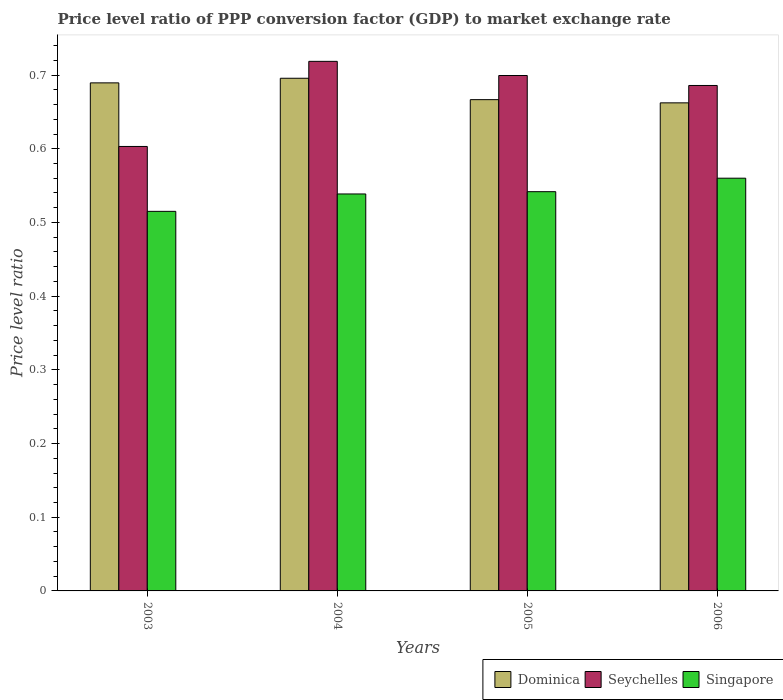How many different coloured bars are there?
Offer a very short reply. 3. How many groups of bars are there?
Provide a succinct answer. 4. How many bars are there on the 4th tick from the left?
Ensure brevity in your answer.  3. What is the label of the 3rd group of bars from the left?
Your answer should be compact. 2005. In how many cases, is the number of bars for a given year not equal to the number of legend labels?
Provide a short and direct response. 0. What is the price level ratio in Dominica in 2003?
Keep it short and to the point. 0.69. Across all years, what is the maximum price level ratio in Singapore?
Give a very brief answer. 0.56. Across all years, what is the minimum price level ratio in Dominica?
Your answer should be compact. 0.66. In which year was the price level ratio in Seychelles maximum?
Offer a terse response. 2004. In which year was the price level ratio in Singapore minimum?
Offer a terse response. 2003. What is the total price level ratio in Dominica in the graph?
Make the answer very short. 2.71. What is the difference between the price level ratio in Seychelles in 2005 and that in 2006?
Your answer should be very brief. 0.01. What is the difference between the price level ratio in Dominica in 2003 and the price level ratio in Singapore in 2004?
Your answer should be very brief. 0.15. What is the average price level ratio in Dominica per year?
Offer a terse response. 0.68. In the year 2003, what is the difference between the price level ratio in Singapore and price level ratio in Seychelles?
Offer a very short reply. -0.09. What is the ratio of the price level ratio in Dominica in 2004 to that in 2005?
Provide a short and direct response. 1.04. Is the price level ratio in Seychelles in 2004 less than that in 2006?
Keep it short and to the point. No. Is the difference between the price level ratio in Singapore in 2003 and 2006 greater than the difference between the price level ratio in Seychelles in 2003 and 2006?
Your response must be concise. Yes. What is the difference between the highest and the second highest price level ratio in Dominica?
Provide a succinct answer. 0.01. What is the difference between the highest and the lowest price level ratio in Singapore?
Provide a succinct answer. 0.04. What does the 3rd bar from the left in 2005 represents?
Your answer should be very brief. Singapore. What does the 2nd bar from the right in 2006 represents?
Give a very brief answer. Seychelles. How many bars are there?
Ensure brevity in your answer.  12. Are the values on the major ticks of Y-axis written in scientific E-notation?
Your answer should be very brief. No. Does the graph contain any zero values?
Ensure brevity in your answer.  No. Does the graph contain grids?
Provide a succinct answer. No. How many legend labels are there?
Offer a terse response. 3. How are the legend labels stacked?
Offer a very short reply. Horizontal. What is the title of the graph?
Provide a succinct answer. Price level ratio of PPP conversion factor (GDP) to market exchange rate. Does "Zimbabwe" appear as one of the legend labels in the graph?
Offer a very short reply. No. What is the label or title of the X-axis?
Offer a very short reply. Years. What is the label or title of the Y-axis?
Offer a very short reply. Price level ratio. What is the Price level ratio of Dominica in 2003?
Your answer should be very brief. 0.69. What is the Price level ratio in Seychelles in 2003?
Provide a succinct answer. 0.6. What is the Price level ratio in Singapore in 2003?
Make the answer very short. 0.52. What is the Price level ratio of Dominica in 2004?
Provide a succinct answer. 0.7. What is the Price level ratio in Seychelles in 2004?
Your answer should be compact. 0.72. What is the Price level ratio in Singapore in 2004?
Ensure brevity in your answer.  0.54. What is the Price level ratio in Dominica in 2005?
Ensure brevity in your answer.  0.67. What is the Price level ratio of Seychelles in 2005?
Offer a terse response. 0.7. What is the Price level ratio in Singapore in 2005?
Your answer should be very brief. 0.54. What is the Price level ratio of Dominica in 2006?
Keep it short and to the point. 0.66. What is the Price level ratio in Seychelles in 2006?
Your response must be concise. 0.69. What is the Price level ratio in Singapore in 2006?
Your answer should be compact. 0.56. Across all years, what is the maximum Price level ratio of Dominica?
Make the answer very short. 0.7. Across all years, what is the maximum Price level ratio in Seychelles?
Ensure brevity in your answer.  0.72. Across all years, what is the maximum Price level ratio in Singapore?
Offer a terse response. 0.56. Across all years, what is the minimum Price level ratio in Dominica?
Your answer should be compact. 0.66. Across all years, what is the minimum Price level ratio in Seychelles?
Give a very brief answer. 0.6. Across all years, what is the minimum Price level ratio of Singapore?
Offer a very short reply. 0.52. What is the total Price level ratio of Dominica in the graph?
Make the answer very short. 2.71. What is the total Price level ratio in Seychelles in the graph?
Offer a very short reply. 2.71. What is the total Price level ratio in Singapore in the graph?
Provide a succinct answer. 2.16. What is the difference between the Price level ratio in Dominica in 2003 and that in 2004?
Your response must be concise. -0.01. What is the difference between the Price level ratio of Seychelles in 2003 and that in 2004?
Your answer should be very brief. -0.12. What is the difference between the Price level ratio in Singapore in 2003 and that in 2004?
Provide a short and direct response. -0.02. What is the difference between the Price level ratio in Dominica in 2003 and that in 2005?
Your response must be concise. 0.02. What is the difference between the Price level ratio in Seychelles in 2003 and that in 2005?
Keep it short and to the point. -0.1. What is the difference between the Price level ratio in Singapore in 2003 and that in 2005?
Provide a short and direct response. -0.03. What is the difference between the Price level ratio of Dominica in 2003 and that in 2006?
Your answer should be very brief. 0.03. What is the difference between the Price level ratio of Seychelles in 2003 and that in 2006?
Make the answer very short. -0.08. What is the difference between the Price level ratio in Singapore in 2003 and that in 2006?
Ensure brevity in your answer.  -0.04. What is the difference between the Price level ratio of Dominica in 2004 and that in 2005?
Your answer should be very brief. 0.03. What is the difference between the Price level ratio of Seychelles in 2004 and that in 2005?
Keep it short and to the point. 0.02. What is the difference between the Price level ratio of Singapore in 2004 and that in 2005?
Provide a succinct answer. -0. What is the difference between the Price level ratio of Dominica in 2004 and that in 2006?
Offer a very short reply. 0.03. What is the difference between the Price level ratio in Seychelles in 2004 and that in 2006?
Offer a very short reply. 0.03. What is the difference between the Price level ratio in Singapore in 2004 and that in 2006?
Offer a very short reply. -0.02. What is the difference between the Price level ratio of Dominica in 2005 and that in 2006?
Your response must be concise. 0. What is the difference between the Price level ratio in Seychelles in 2005 and that in 2006?
Your answer should be very brief. 0.01. What is the difference between the Price level ratio of Singapore in 2005 and that in 2006?
Offer a terse response. -0.02. What is the difference between the Price level ratio in Dominica in 2003 and the Price level ratio in Seychelles in 2004?
Your answer should be compact. -0.03. What is the difference between the Price level ratio in Dominica in 2003 and the Price level ratio in Singapore in 2004?
Offer a very short reply. 0.15. What is the difference between the Price level ratio of Seychelles in 2003 and the Price level ratio of Singapore in 2004?
Provide a succinct answer. 0.06. What is the difference between the Price level ratio in Dominica in 2003 and the Price level ratio in Seychelles in 2005?
Your answer should be very brief. -0.01. What is the difference between the Price level ratio in Dominica in 2003 and the Price level ratio in Singapore in 2005?
Your answer should be very brief. 0.15. What is the difference between the Price level ratio in Seychelles in 2003 and the Price level ratio in Singapore in 2005?
Make the answer very short. 0.06. What is the difference between the Price level ratio in Dominica in 2003 and the Price level ratio in Seychelles in 2006?
Offer a terse response. 0. What is the difference between the Price level ratio in Dominica in 2003 and the Price level ratio in Singapore in 2006?
Your response must be concise. 0.13. What is the difference between the Price level ratio of Seychelles in 2003 and the Price level ratio of Singapore in 2006?
Provide a short and direct response. 0.04. What is the difference between the Price level ratio in Dominica in 2004 and the Price level ratio in Seychelles in 2005?
Provide a short and direct response. -0. What is the difference between the Price level ratio in Dominica in 2004 and the Price level ratio in Singapore in 2005?
Provide a succinct answer. 0.15. What is the difference between the Price level ratio of Seychelles in 2004 and the Price level ratio of Singapore in 2005?
Your response must be concise. 0.18. What is the difference between the Price level ratio in Dominica in 2004 and the Price level ratio in Seychelles in 2006?
Give a very brief answer. 0.01. What is the difference between the Price level ratio of Dominica in 2004 and the Price level ratio of Singapore in 2006?
Your response must be concise. 0.14. What is the difference between the Price level ratio in Seychelles in 2004 and the Price level ratio in Singapore in 2006?
Ensure brevity in your answer.  0.16. What is the difference between the Price level ratio of Dominica in 2005 and the Price level ratio of Seychelles in 2006?
Your response must be concise. -0.02. What is the difference between the Price level ratio of Dominica in 2005 and the Price level ratio of Singapore in 2006?
Your answer should be very brief. 0.11. What is the difference between the Price level ratio of Seychelles in 2005 and the Price level ratio of Singapore in 2006?
Give a very brief answer. 0.14. What is the average Price level ratio of Dominica per year?
Provide a short and direct response. 0.68. What is the average Price level ratio of Seychelles per year?
Give a very brief answer. 0.68. What is the average Price level ratio in Singapore per year?
Offer a terse response. 0.54. In the year 2003, what is the difference between the Price level ratio in Dominica and Price level ratio in Seychelles?
Offer a terse response. 0.09. In the year 2003, what is the difference between the Price level ratio of Dominica and Price level ratio of Singapore?
Keep it short and to the point. 0.17. In the year 2003, what is the difference between the Price level ratio of Seychelles and Price level ratio of Singapore?
Keep it short and to the point. 0.09. In the year 2004, what is the difference between the Price level ratio of Dominica and Price level ratio of Seychelles?
Ensure brevity in your answer.  -0.02. In the year 2004, what is the difference between the Price level ratio in Dominica and Price level ratio in Singapore?
Your answer should be very brief. 0.16. In the year 2004, what is the difference between the Price level ratio of Seychelles and Price level ratio of Singapore?
Your answer should be very brief. 0.18. In the year 2005, what is the difference between the Price level ratio in Dominica and Price level ratio in Seychelles?
Keep it short and to the point. -0.03. In the year 2005, what is the difference between the Price level ratio in Dominica and Price level ratio in Singapore?
Keep it short and to the point. 0.12. In the year 2005, what is the difference between the Price level ratio of Seychelles and Price level ratio of Singapore?
Give a very brief answer. 0.16. In the year 2006, what is the difference between the Price level ratio of Dominica and Price level ratio of Seychelles?
Provide a succinct answer. -0.02. In the year 2006, what is the difference between the Price level ratio in Dominica and Price level ratio in Singapore?
Your answer should be compact. 0.1. In the year 2006, what is the difference between the Price level ratio of Seychelles and Price level ratio of Singapore?
Provide a succinct answer. 0.13. What is the ratio of the Price level ratio of Dominica in 2003 to that in 2004?
Ensure brevity in your answer.  0.99. What is the ratio of the Price level ratio in Seychelles in 2003 to that in 2004?
Your response must be concise. 0.84. What is the ratio of the Price level ratio of Singapore in 2003 to that in 2004?
Keep it short and to the point. 0.96. What is the ratio of the Price level ratio of Dominica in 2003 to that in 2005?
Keep it short and to the point. 1.03. What is the ratio of the Price level ratio in Seychelles in 2003 to that in 2005?
Provide a succinct answer. 0.86. What is the ratio of the Price level ratio in Singapore in 2003 to that in 2005?
Ensure brevity in your answer.  0.95. What is the ratio of the Price level ratio of Dominica in 2003 to that in 2006?
Provide a succinct answer. 1.04. What is the ratio of the Price level ratio in Seychelles in 2003 to that in 2006?
Make the answer very short. 0.88. What is the ratio of the Price level ratio in Singapore in 2003 to that in 2006?
Provide a short and direct response. 0.92. What is the ratio of the Price level ratio in Dominica in 2004 to that in 2005?
Your response must be concise. 1.04. What is the ratio of the Price level ratio in Seychelles in 2004 to that in 2005?
Ensure brevity in your answer.  1.03. What is the ratio of the Price level ratio of Dominica in 2004 to that in 2006?
Offer a terse response. 1.05. What is the ratio of the Price level ratio of Seychelles in 2004 to that in 2006?
Your answer should be compact. 1.05. What is the ratio of the Price level ratio of Singapore in 2004 to that in 2006?
Your answer should be very brief. 0.96. What is the ratio of the Price level ratio in Dominica in 2005 to that in 2006?
Give a very brief answer. 1.01. What is the ratio of the Price level ratio of Seychelles in 2005 to that in 2006?
Offer a very short reply. 1.02. What is the ratio of the Price level ratio of Singapore in 2005 to that in 2006?
Your answer should be compact. 0.97. What is the difference between the highest and the second highest Price level ratio of Dominica?
Your answer should be compact. 0.01. What is the difference between the highest and the second highest Price level ratio of Seychelles?
Your response must be concise. 0.02. What is the difference between the highest and the second highest Price level ratio of Singapore?
Provide a succinct answer. 0.02. What is the difference between the highest and the lowest Price level ratio of Dominica?
Give a very brief answer. 0.03. What is the difference between the highest and the lowest Price level ratio of Seychelles?
Offer a very short reply. 0.12. What is the difference between the highest and the lowest Price level ratio in Singapore?
Ensure brevity in your answer.  0.04. 